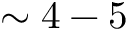<formula> <loc_0><loc_0><loc_500><loc_500>\sim 4 - 5</formula> 